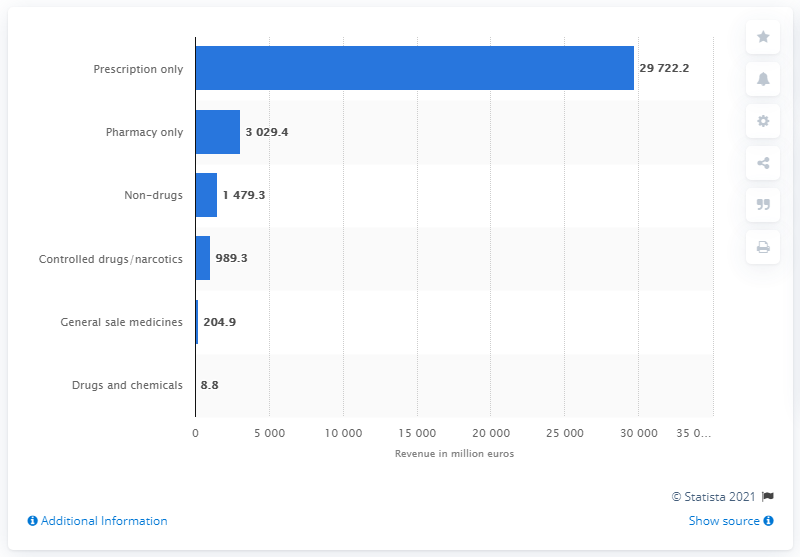Highlight a few significant elements in this photo. In Germany in 2019, the value of prescription medication was approximately 29,722.2 euros. 